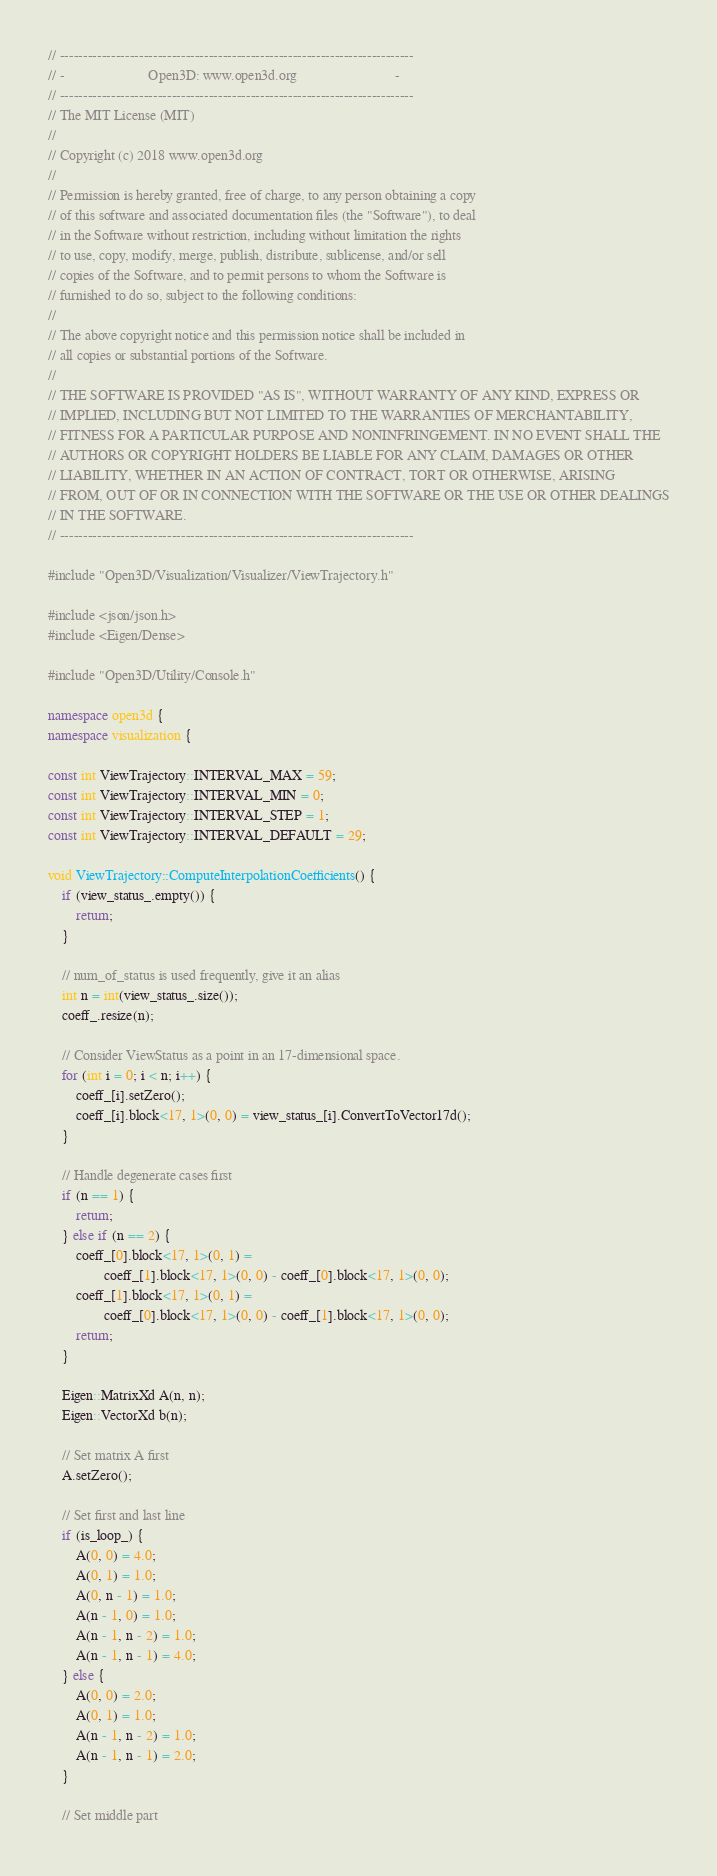<code> <loc_0><loc_0><loc_500><loc_500><_C++_>// ----------------------------------------------------------------------------
// -                        Open3D: www.open3d.org                            -
// ----------------------------------------------------------------------------
// The MIT License (MIT)
//
// Copyright (c) 2018 www.open3d.org
//
// Permission is hereby granted, free of charge, to any person obtaining a copy
// of this software and associated documentation files (the "Software"), to deal
// in the Software without restriction, including without limitation the rights
// to use, copy, modify, merge, publish, distribute, sublicense, and/or sell
// copies of the Software, and to permit persons to whom the Software is
// furnished to do so, subject to the following conditions:
//
// The above copyright notice and this permission notice shall be included in
// all copies or substantial portions of the Software.
//
// THE SOFTWARE IS PROVIDED "AS IS", WITHOUT WARRANTY OF ANY KIND, EXPRESS OR
// IMPLIED, INCLUDING BUT NOT LIMITED TO THE WARRANTIES OF MERCHANTABILITY,
// FITNESS FOR A PARTICULAR PURPOSE AND NONINFRINGEMENT. IN NO EVENT SHALL THE
// AUTHORS OR COPYRIGHT HOLDERS BE LIABLE FOR ANY CLAIM, DAMAGES OR OTHER
// LIABILITY, WHETHER IN AN ACTION OF CONTRACT, TORT OR OTHERWISE, ARISING
// FROM, OUT OF OR IN CONNECTION WITH THE SOFTWARE OR THE USE OR OTHER DEALINGS
// IN THE SOFTWARE.
// ----------------------------------------------------------------------------

#include "Open3D/Visualization/Visualizer/ViewTrajectory.h"

#include <json/json.h>
#include <Eigen/Dense>

#include "Open3D/Utility/Console.h"

namespace open3d {
namespace visualization {

const int ViewTrajectory::INTERVAL_MAX = 59;
const int ViewTrajectory::INTERVAL_MIN = 0;
const int ViewTrajectory::INTERVAL_STEP = 1;
const int ViewTrajectory::INTERVAL_DEFAULT = 29;

void ViewTrajectory::ComputeInterpolationCoefficients() {
    if (view_status_.empty()) {
        return;
    }

    // num_of_status is used frequently, give it an alias
    int n = int(view_status_.size());
    coeff_.resize(n);

    // Consider ViewStatus as a point in an 17-dimensional space.
    for (int i = 0; i < n; i++) {
        coeff_[i].setZero();
        coeff_[i].block<17, 1>(0, 0) = view_status_[i].ConvertToVector17d();
    }

    // Handle degenerate cases first
    if (n == 1) {
        return;
    } else if (n == 2) {
        coeff_[0].block<17, 1>(0, 1) =
                coeff_[1].block<17, 1>(0, 0) - coeff_[0].block<17, 1>(0, 0);
        coeff_[1].block<17, 1>(0, 1) =
                coeff_[0].block<17, 1>(0, 0) - coeff_[1].block<17, 1>(0, 0);
        return;
    }

    Eigen::MatrixXd A(n, n);
    Eigen::VectorXd b(n);

    // Set matrix A first
    A.setZero();

    // Set first and last line
    if (is_loop_) {
        A(0, 0) = 4.0;
        A(0, 1) = 1.0;
        A(0, n - 1) = 1.0;
        A(n - 1, 0) = 1.0;
        A(n - 1, n - 2) = 1.0;
        A(n - 1, n - 1) = 4.0;
    } else {
        A(0, 0) = 2.0;
        A(0, 1) = 1.0;
        A(n - 1, n - 2) = 1.0;
        A(n - 1, n - 1) = 2.0;
    }

    // Set middle part</code> 